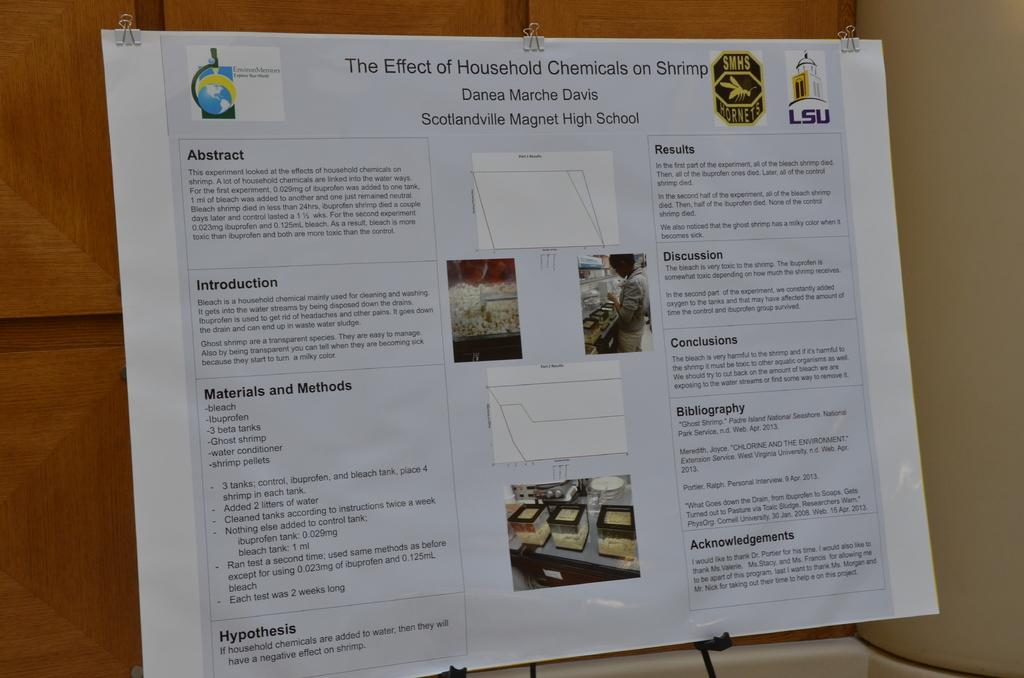<image>
Share a concise interpretation of the image provided. A school project dealing with the effects on household chemicals on shrimp sits on an easel for people to read. 